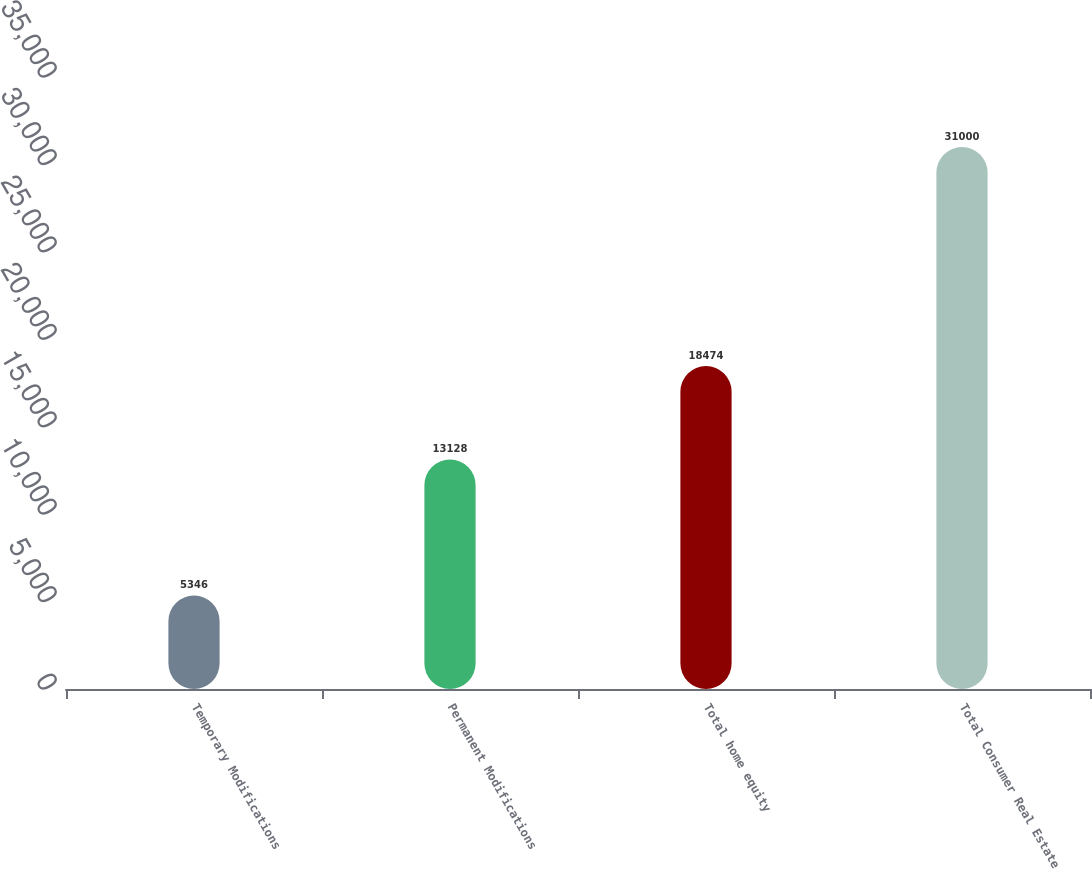Convert chart to OTSL. <chart><loc_0><loc_0><loc_500><loc_500><bar_chart><fcel>Temporary Modifications<fcel>Permanent Modifications<fcel>Total home equity<fcel>Total Consumer Real Estate<nl><fcel>5346<fcel>13128<fcel>18474<fcel>31000<nl></chart> 